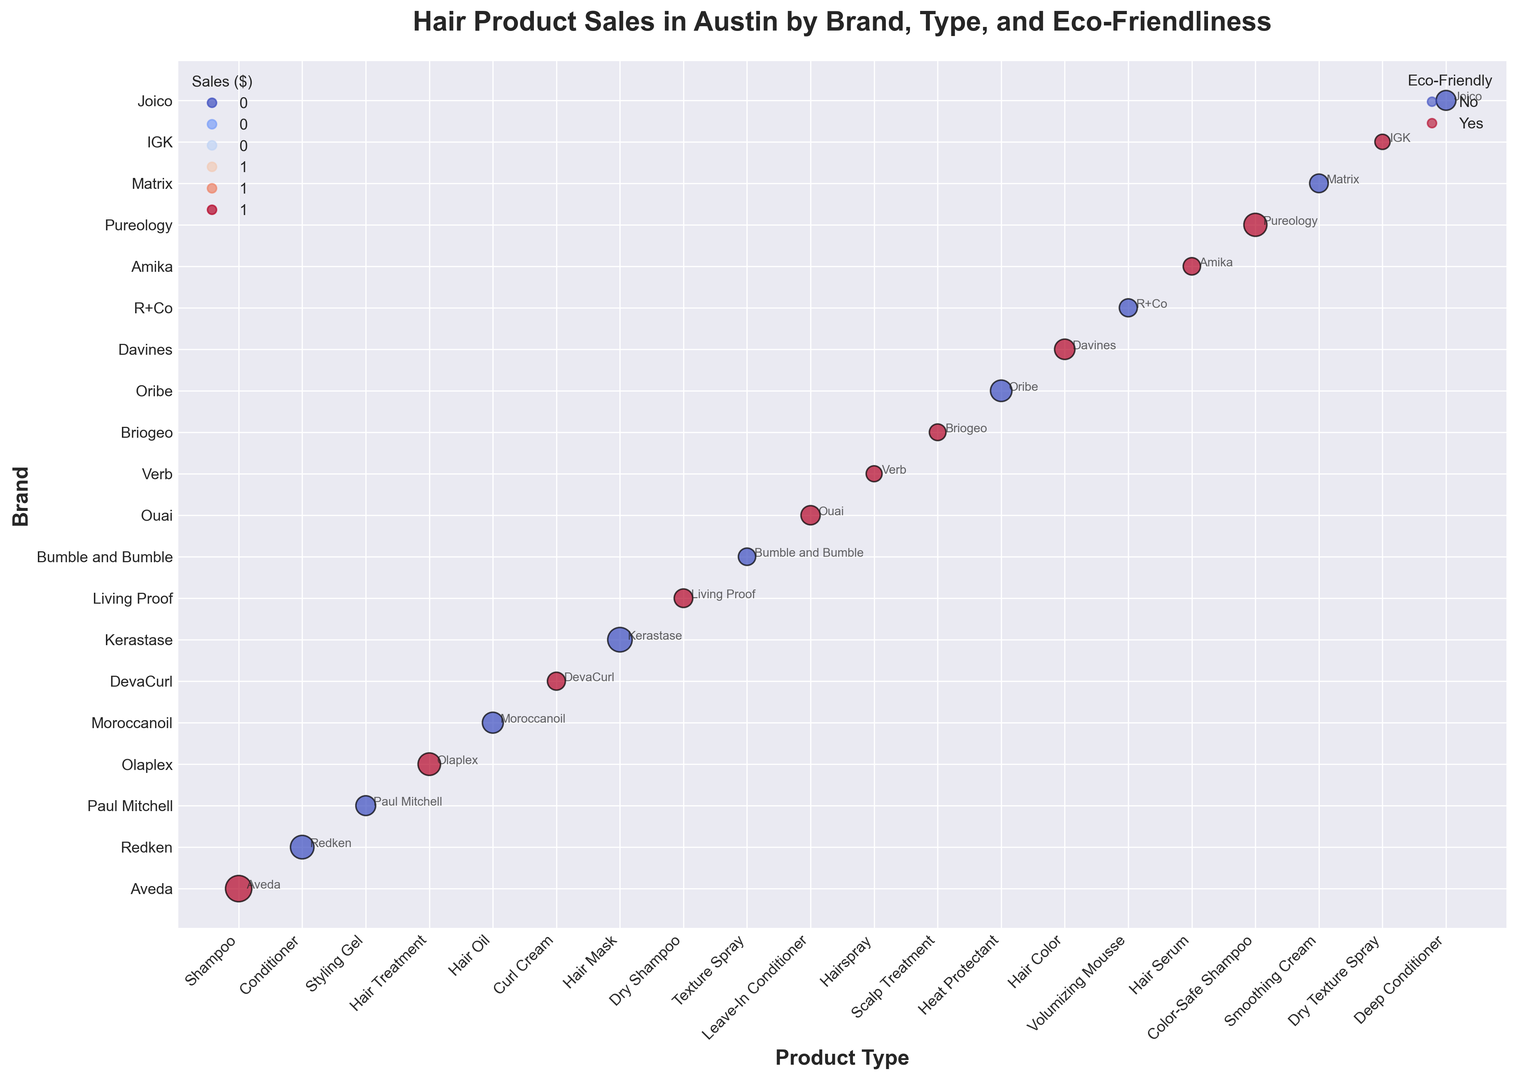What product type has the highest sales? The bubble representing the largest sales value stands for the Aveda Shampoo. On the chart, it's the biggest bubble, indicating the highest sales figure, which is $150,000.
Answer: Shampoo Which eco-friendly product has the highest sales? By observing the bubble colors (red for non-eco-friendly and blue for eco-friendly), the largest blue bubble corresponds to Aveda. Therefore, the Aveda Shampoo, which is eco-friendly, has the highest sales among the eco-friendly products.
Answer: Aveda Shampoo Which brand has the least sales, and what's the product type? The smallest bubble on the chart represents the lowest sales, which is $50,000. This corresponds to the IGK brand with the Dry Texture Spray product type.
Answer: IGK, Dry Texture Spray Which non-eco-friendly product type has the largest sales gap compared to the least sold non-eco-friendly product? The largest non-eco-friendly sale is from Kerastase Hair Mask ($130,000), and the smallest is Bumble and Bumble Texture Spray ($65,000). The gap between these two is $130,000 - $65,000 = $65,000.
Answer: $65,000 What's the average sales figure for the eco-friendly products? Summing up sales of eco-friendly products: 150,000 + 110,000 + 70,000 + 75,000 + 80,000 + 55,000 + 60,000 + 90,000 + 65,000 + 115,000 + 50,000 = 920,000. Counting these products: 11. Average = 920,000 / 11 = $83,636.
Answer: $83,636 Do eco-friendly products tend to have higher or lower sales on average compared to non-eco-friendly products? Calculate the average sales for both categories. Eco-friendly: $83,636. Non-eco-friendly: 
(120,000 + 85,000 + 95,000 + 130,000 + 65,000 + 100,000 + 70,000 + 75,000 + 85,000) = 825,000 / 9 = $91,667. Eco-friendly products have lower sales on average.
Answer: Lower Which brand has most products in the eco-friendly category, and how many? By observing bubble colors (blue for eco-friendly), count the brands. Several have one product, but none have more than one. Thus, each brand represented as eco-friendly has only one product each.
Answer: Multiple brands, 1 each What's the total sales for hair treatments (group including Hair Treatment, Scalp Treatment, Deep Conditioner)? Sum the sales for these types: Olaplex Hair Treatment ($110,000) + Briogeo Scalp Treatment ($60,000) + Joico Deep Conditioner ($85,000) = $255,000.
Answer: $255,000 Which brand and product type have the highest sales in the non-eco-friendly category? Refer to the non-blue largest bubble, which represents Kerastase Hair Mask with $130,000 sales.
Answer: Kerastase, Hair Mask 